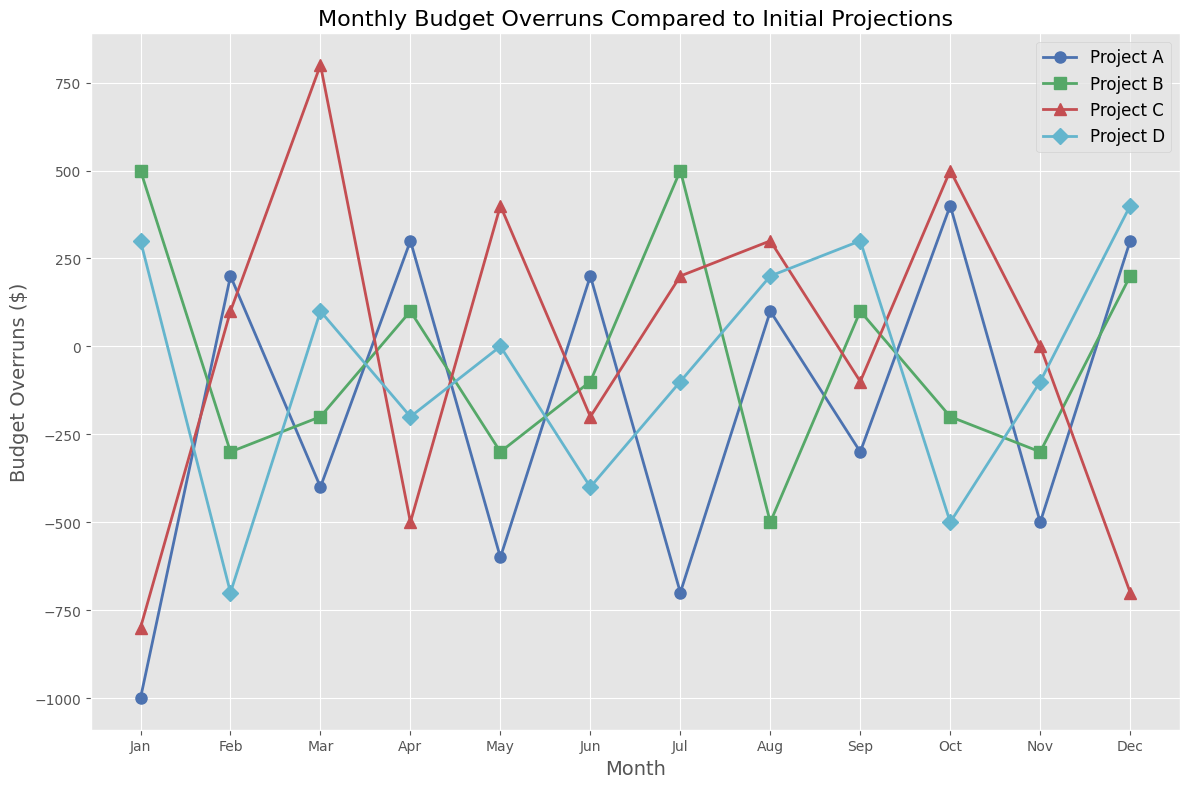What's the smallest budget overrun in Project A? To find the smallest budget overrun for Project A, look at all the data points for that project. The data for Project A is: -1000, 200, -400, 300, -600, 200, -700, 100, -300, 400, -500, 300. The smallest value is -1000.
Answer: -1000 Which project had the highest budget overrun in July? Find the data for each project in July. Project A: -700, Project B: 500, Project C: 200, Project D: -100. The highest value is 500 in Project B.
Answer: Project B Between which months did Project C's budget overrun change the most? Look at the differences between consecutive months for Project C. From Jan to Feb: -900; Feb to Mar: 700; Mar to Apr: -1300; Apr to May: 900; May to Jun: -600; Jun to Jul: 400; Jul to Aug: 100; Aug to Sep: -400; Sep to Oct: 600; Oct to Nov: -500; Nov to Dec: -700. The largest change is from Mar to Apr, 1300.
Answer: Mar to Apr When did Project D have its most positive budget overrun? Locate the highest value for Project D. The data is Jan: 300, Feb: -700, Mar: 100, Apr: -200, May: 0, Jun: -400, Jul: -100, Aug: 200, Sep: 300, Oct: -500, Nov: -100, Dec: 400. The most positive is 400 in December.
Answer: December What's the average budget overrun for Project B in the first quarter? Calculate the average for Project B from Jan to Mar. The values are: 500, -300, -200. Sum = 500 + (-300) + (-200) = 0. The average is 0/3 = 0.
Answer: 0 Which project had a budget overrun closest to zero in May? Find the May data: Project A: -600, Project B: -300, Project C: 400, Project D: 0. The value closest to zero is 0 in Project D.
Answer: Project D Was Project C ever below -700? Check the data for Project C. The smallest value is -700 in December, so Project C has not been below -700.
Answer: No What's the total budget overrun of Project A and Project D in October? Add the values for Project A and D in October. Project A: 400, Project D: -500. Sum = 400 + (-500) = -100.
Answer: -100 Which two projects had budget overruns of opposite signs in June? Compare the data of each project for June. Project A: 200, Project B: -100, Project C: -200, Project D: -400. Projects A and B have opposite signs.
Answer: Project A and Project B 